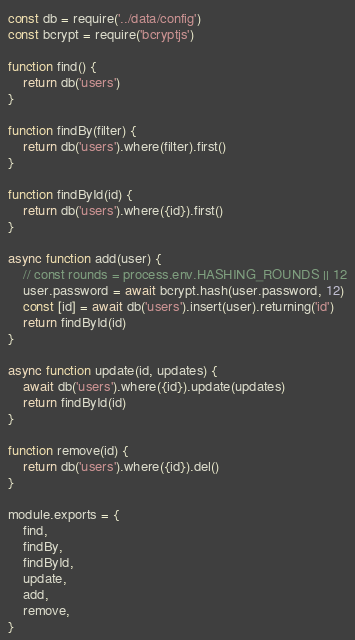<code> <loc_0><loc_0><loc_500><loc_500><_JavaScript_>const db = require('../data/config')
const bcrypt = require('bcryptjs')

function find() {
    return db('users')
}

function findBy(filter) {
    return db('users').where(filter).first()
}

function findById(id) {
    return db('users').where({id}).first()
}

async function add(user) {
    // const rounds = process.env.HASHING_ROUNDS || 12
    user.password = await bcrypt.hash(user.password, 12)
    const [id] = await db('users').insert(user).returning('id')
    return findById(id)
}

async function update(id, updates) {
    await db('users').where({id}).update(updates)
    return findById(id)
}

function remove(id) {
    return db('users').where({id}).del()
}

module.exports = {
    find,
    findBy,
    findById,
    update,
    add,
    remove,
}
</code> 